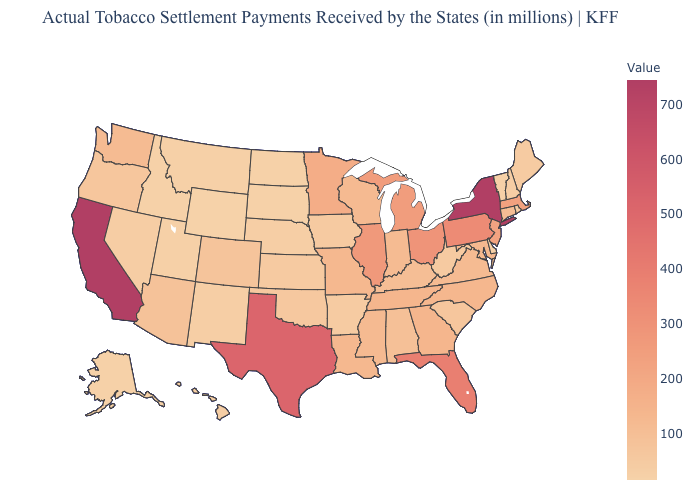Which states have the lowest value in the USA?
Keep it brief. Wyoming. Does New Mexico have the lowest value in the USA?
Quick response, please. No. Among the states that border North Carolina , does Tennessee have the lowest value?
Be succinct. No. Does Wyoming have the lowest value in the USA?
Short answer required. Yes. Is the legend a continuous bar?
Keep it brief. Yes. Does New Mexico have a higher value than Washington?
Short answer required. No. 